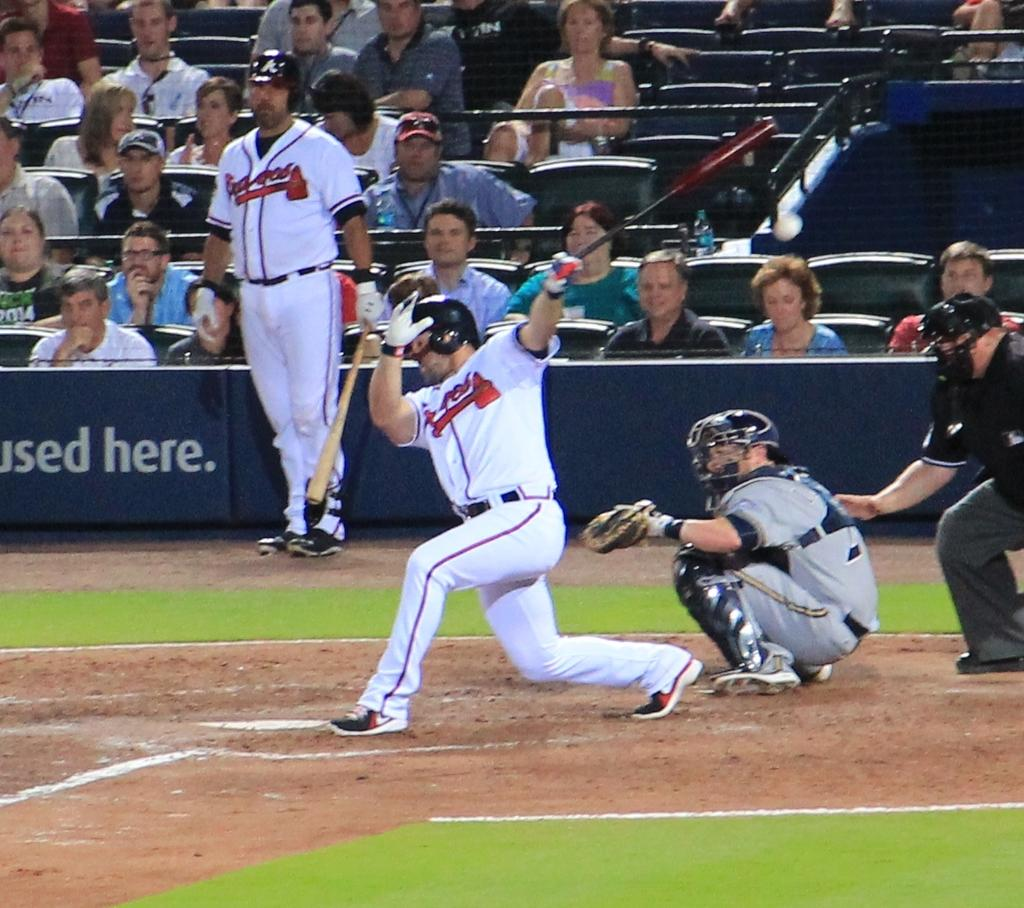Provide a one-sentence caption for the provided image. A partially visible ballpark ad says something is Used Here. 